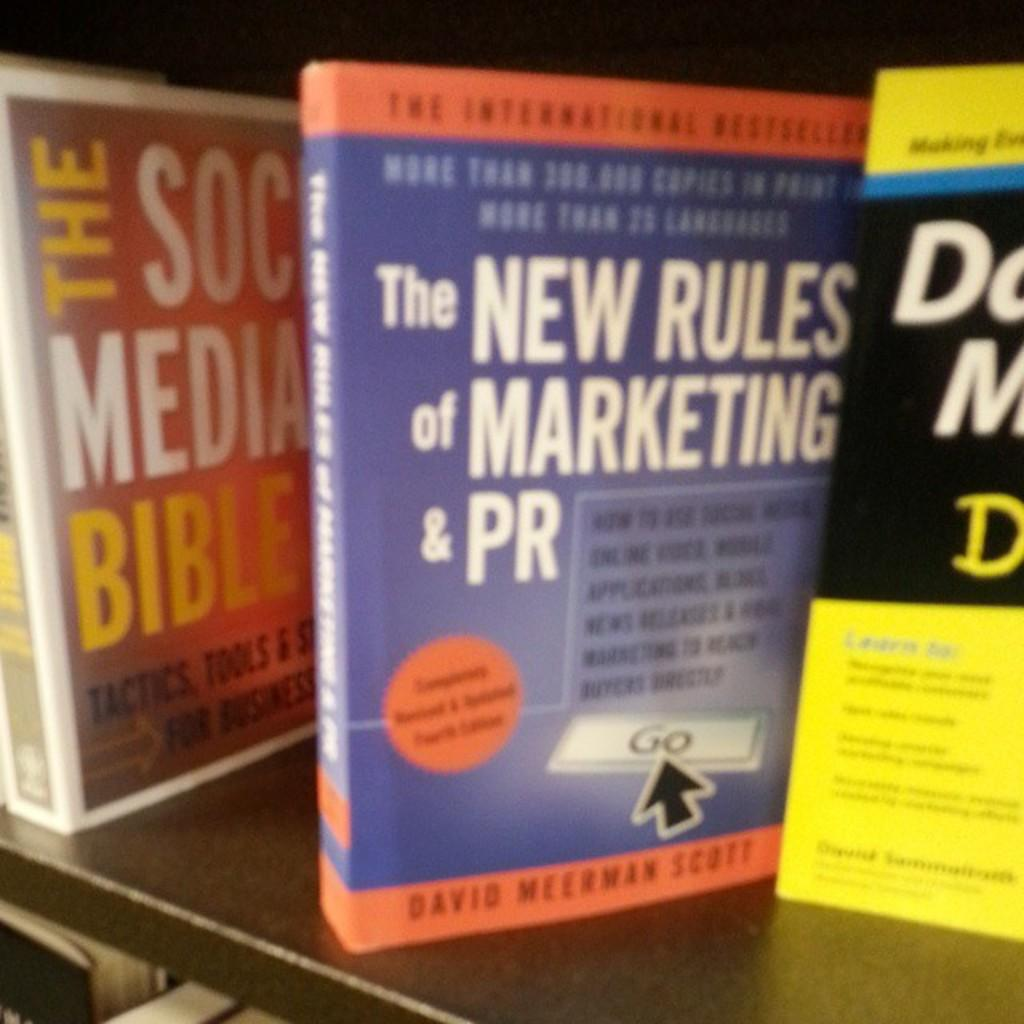Provide a one-sentence caption for the provided image. a book that is about the new rules of marketing and pr. 